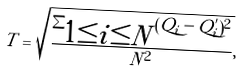<formula> <loc_0><loc_0><loc_500><loc_500>T = \sqrt { \frac { \sum _ { \substack { 1 \leq i \leq N } } ( Q _ { i } - Q ^ { ^ { \prime } } _ { i } ) ^ { 2 } } { N ^ { 2 } } } ,</formula> 